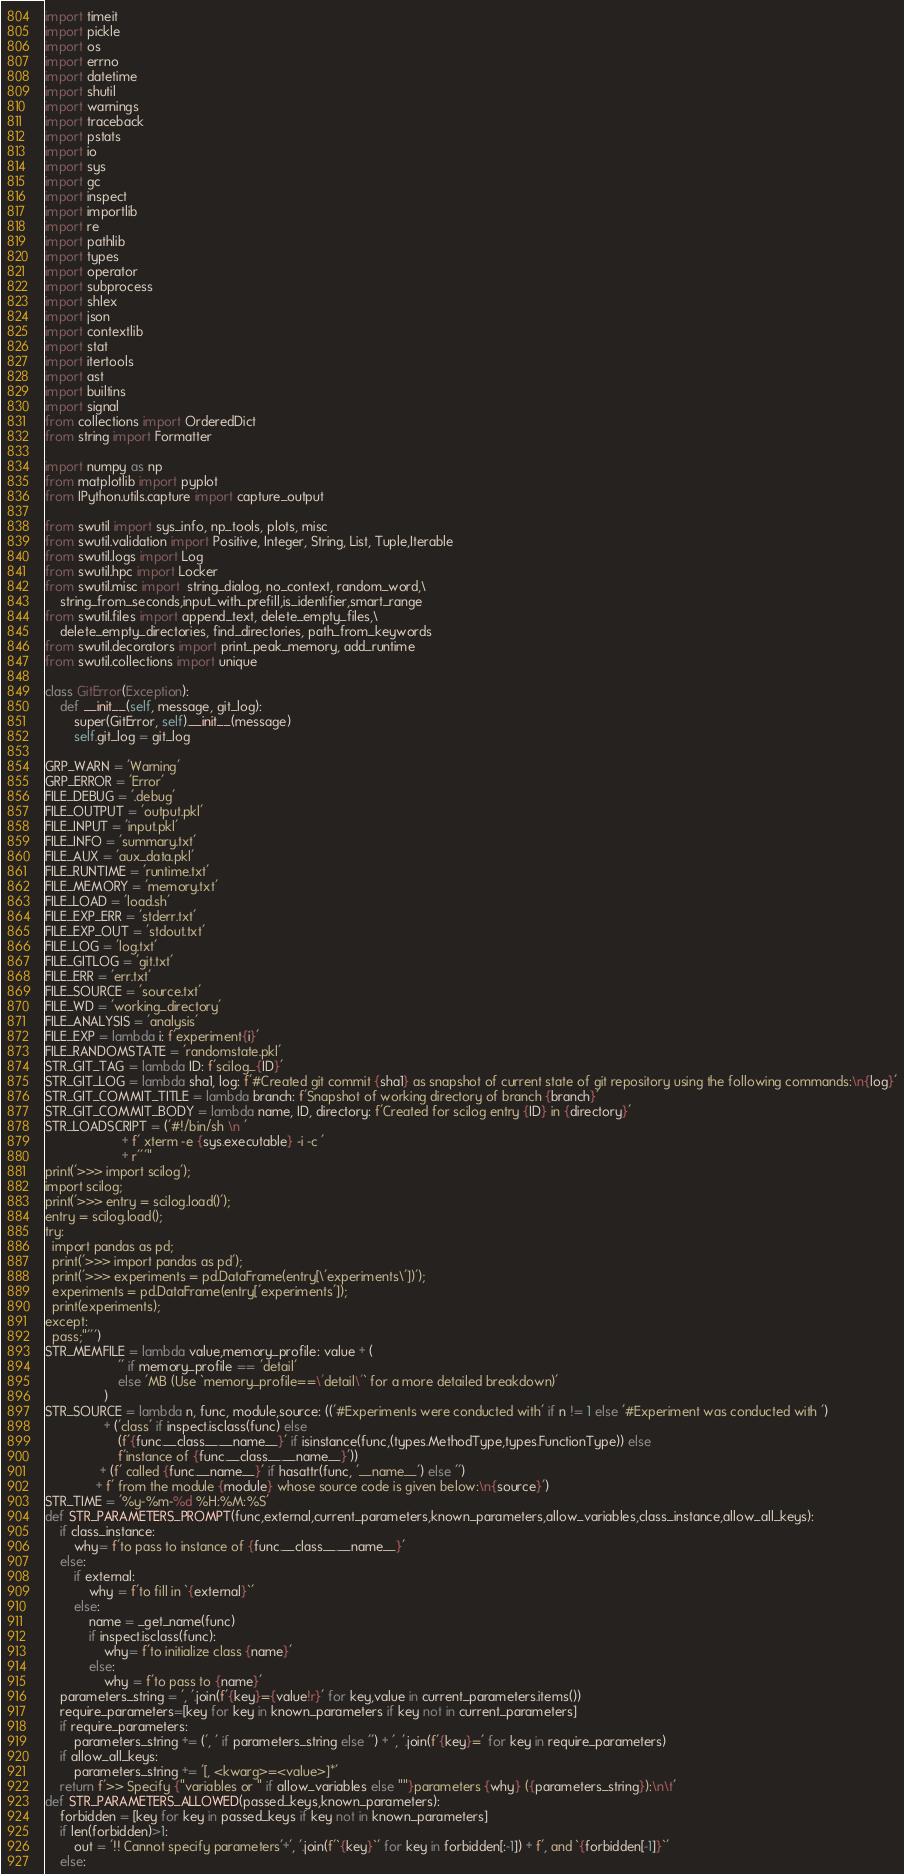Convert code to text. <code><loc_0><loc_0><loc_500><loc_500><_Python_>import timeit
import pickle
import os
import errno
import datetime
import shutil
import warnings
import traceback
import pstats
import io
import sys
import gc
import inspect
import importlib
import re
import pathlib
import types
import operator
import subprocess
import shlex
import json
import contextlib
import stat
import itertools
import ast
import builtins
import signal
from collections import OrderedDict
from string import Formatter

import numpy as np
from matplotlib import pyplot
from IPython.utils.capture import capture_output

from swutil import sys_info, np_tools, plots, misc
from swutil.validation import Positive, Integer, String, List, Tuple,Iterable
from swutil.logs import Log
from swutil.hpc import Locker
from swutil.misc import  string_dialog, no_context, random_word,\
    string_from_seconds,input_with_prefill,is_identifier,smart_range
from swutil.files import append_text, delete_empty_files,\
    delete_empty_directories, find_directories, path_from_keywords
from swutil.decorators import print_peak_memory, add_runtime
from swutil.collections import unique

class GitError(Exception):
    def __init__(self, message, git_log):
        super(GitError, self).__init__(message)
        self.git_log = git_log
        
GRP_WARN = 'Warning'
GRP_ERROR = 'Error'
FILE_DEBUG = '.debug'
FILE_OUTPUT = 'output.pkl'
FILE_INPUT = 'input.pkl'
FILE_INFO = 'summary.txt'
FILE_AUX = 'aux_data.pkl'
FILE_RUNTIME = 'runtime.txt'
FILE_MEMORY = 'memory.txt'
FILE_LOAD = 'load.sh'
FILE_EXP_ERR = 'stderr.txt'
FILE_EXP_OUT = 'stdout.txt'
FILE_LOG = 'log.txt'
FILE_GITLOG = 'git.txt'
FILE_ERR = 'err.txt'
FILE_SOURCE = 'source.txt'
FILE_WD = 'working_directory'
FILE_ANALYSIS = 'analysis'
FILE_EXP = lambda i: f'experiment{i}'
FILE_RANDOMSTATE = 'randomstate.pkl'
STR_GIT_TAG = lambda ID: f'scilog_{ID}'
STR_GIT_LOG = lambda sha1, log: f'#Created git commit {sha1} as snapshot of current state of git repository using the following commands:\n{log}'
STR_GIT_COMMIT_TITLE = lambda branch: f'Snapshot of working directory of branch {branch}'
STR_GIT_COMMIT_BODY = lambda name, ID, directory: f'Created for scilog entry {ID} in {directory}'
STR_LOADSCRIPT = ('#!/bin/sh \n '
                     + f' xterm -e {sys.executable} -i -c '
                     + r'''"
print('>>> import scilog'); 
import scilog;
print('>>> entry = scilog.load()');
entry = scilog.load();
try:
  import pandas as pd;
  print('>>> import pandas as pd');
  print('>>> experiments = pd.DataFrame(entry[\'experiments\'])');
  experiments = pd.DataFrame(entry['experiments']);
  print(experiments);
except:
  pass;"''')
STR_MEMFILE = lambda value,memory_profile: value + (
                    '' if memory_profile == 'detail' 
                    else 'MB (Use `memory_profile==\'detail\'` for a more detailed breakdown)'
                )
STR_SOURCE = lambda n, func, module,source: (('#Experiments were conducted with' if n != 1 else '#Experiment was conducted with ')
                + ('class' if inspect.isclass(func) else  
                    (f'{func.__class__.__name__}' if isinstance(func,(types.MethodType,types.FunctionType)) else 
                    f'instance of {func.__class__.__name__}'))
               + (f' called {func.__name__}' if hasattr(func, '__name__') else '')
              + f' from the module {module} whose source code is given below:\n{source}')
STR_TIME = '%y-%m-%d %H:%M:%S'
def STR_PARAMETERS_PROMPT(func,external,current_parameters,known_parameters,allow_variables,class_instance,allow_all_keys):
    if class_instance:
        why= f'to pass to instance of {func.__class__.__name__}'
    else:
        if external:
            why = f'to fill in `{external}`'
        else:
            name = _get_name(func)
            if inspect.isclass(func):
                why= f'to initialize class {name}'
            else:
                why = f'to pass to {name}'
    parameters_string = ', '.join(f'{key}={value!r}' for key,value in current_parameters.items())
    require_parameters=[key for key in known_parameters if key not in current_parameters]
    if require_parameters:
        parameters_string += (', ' if parameters_string else '') + ', '.join(f'{key}=' for key in require_parameters)
    if allow_all_keys:
        parameters_string += '[, <kwarg>=<value>]*'
    return f'>> Specify {"variables or " if allow_variables else ""}parameters {why} ({parameters_string}):\n\t'
def STR_PARAMETERS_ALLOWED(passed_keys,known_parameters):
    forbidden = [key for key in passed_keys if key not in known_parameters]
    if len(forbidden)>1:
        out = '!! Cannot specify parameters'+', '.join(f'`{key}`' for key in forbidden[:-1]) + f', and `{forbidden[-1]}`'
    else:</code> 